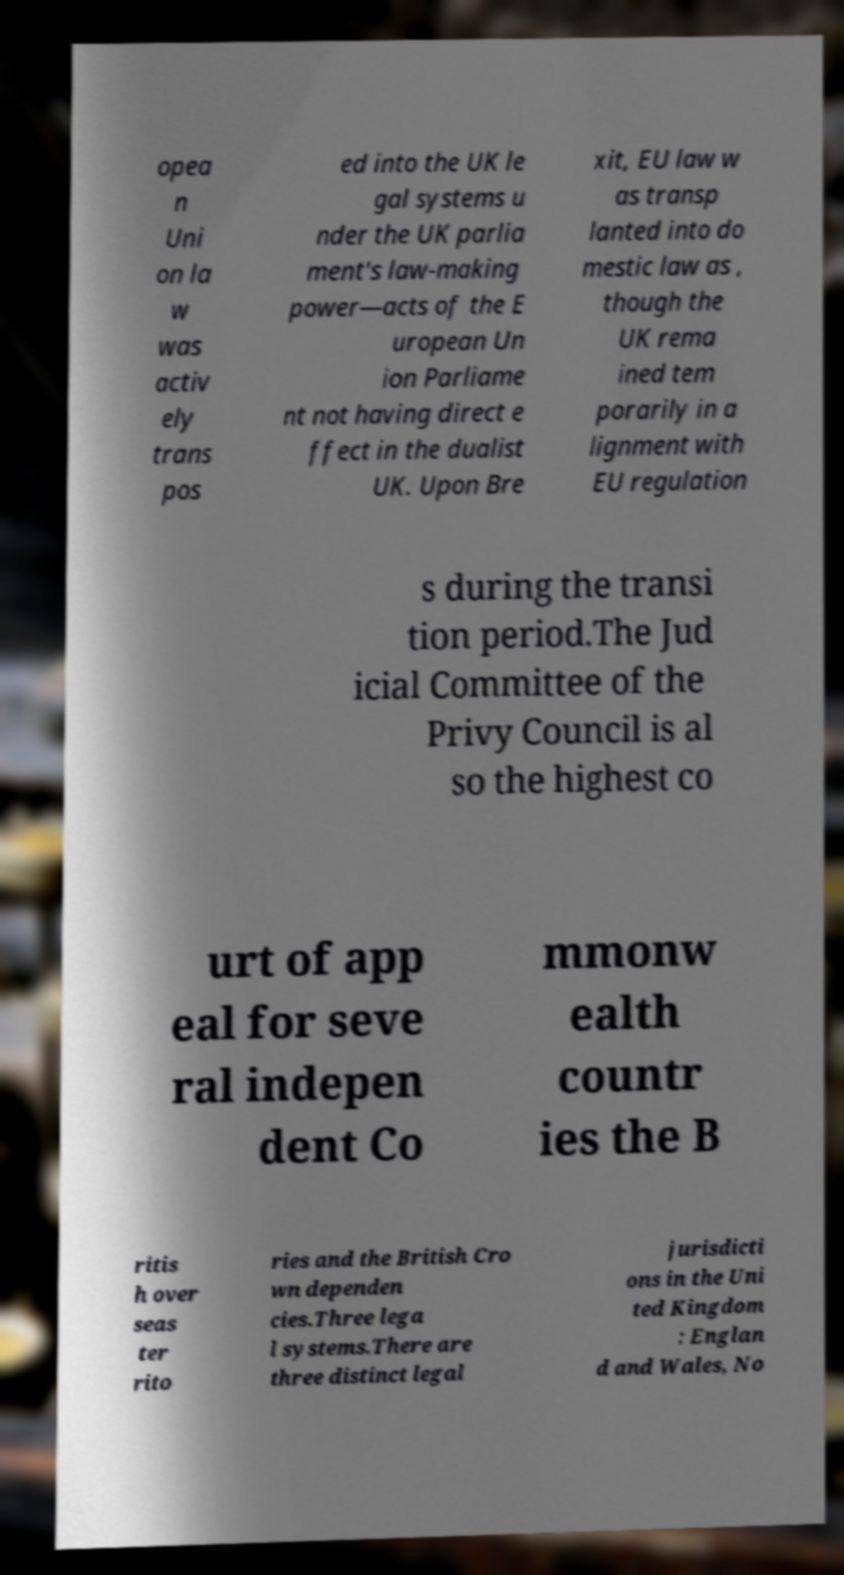There's text embedded in this image that I need extracted. Can you transcribe it verbatim? opea n Uni on la w was activ ely trans pos ed into the UK le gal systems u nder the UK parlia ment's law-making power—acts of the E uropean Un ion Parliame nt not having direct e ffect in the dualist UK. Upon Bre xit, EU law w as transp lanted into do mestic law as , though the UK rema ined tem porarily in a lignment with EU regulation s during the transi tion period.The Jud icial Committee of the Privy Council is al so the highest co urt of app eal for seve ral indepen dent Co mmonw ealth countr ies the B ritis h over seas ter rito ries and the British Cro wn dependen cies.Three lega l systems.There are three distinct legal jurisdicti ons in the Uni ted Kingdom : Englan d and Wales, No 